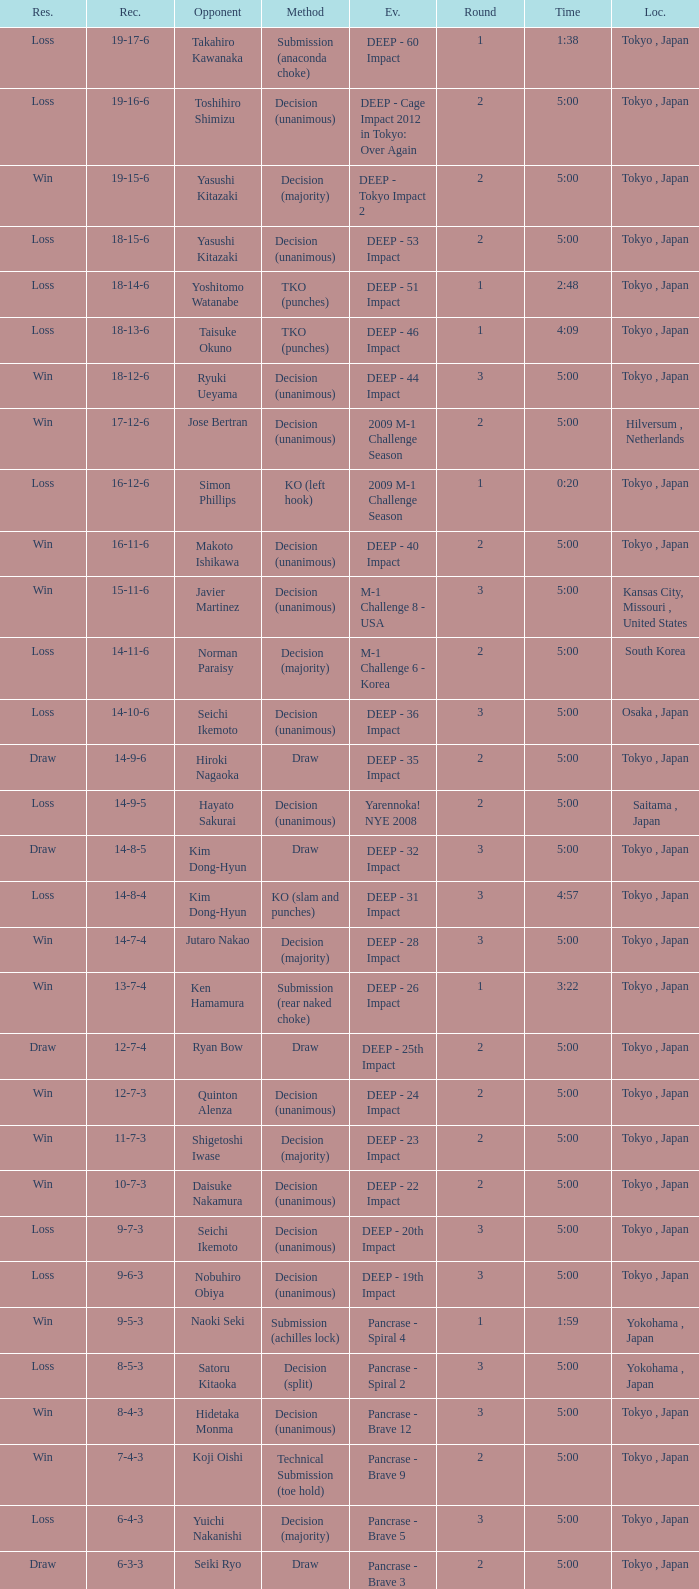What is the location when the method is tko (punches) and the time is 2:48? Tokyo , Japan. 